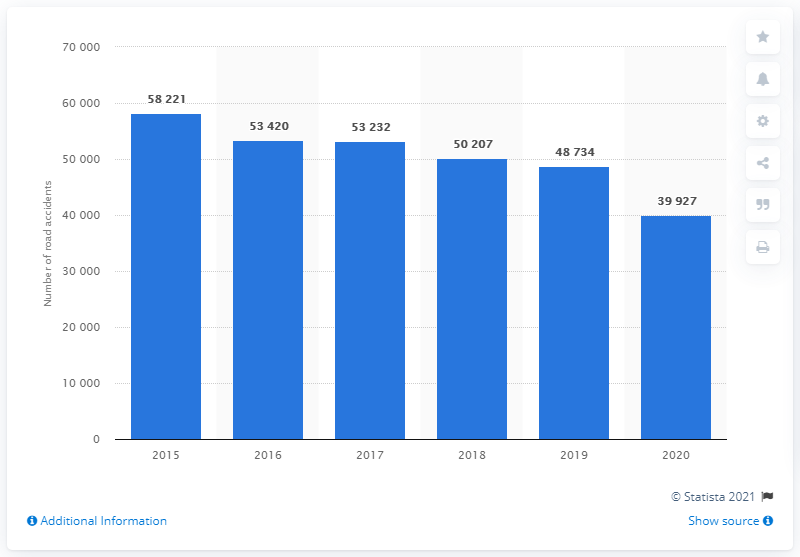List a handful of essential elements in this visual. Since 2015, the number of road accidents involving injured pedestrians in Russia has decreased. In 2020, the traffic safety administration in Russia reported a total of 39,927 road accidents. 